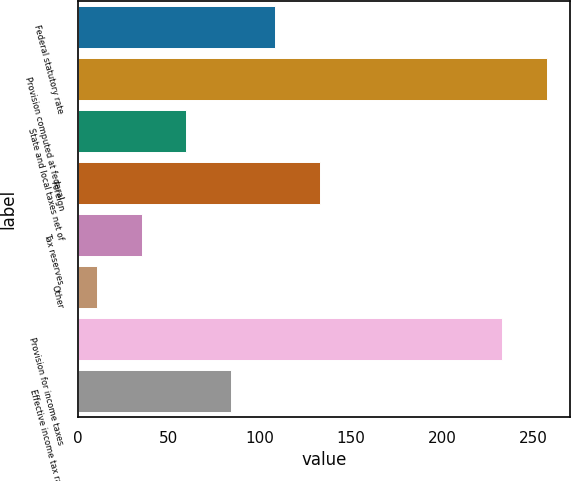Convert chart. <chart><loc_0><loc_0><loc_500><loc_500><bar_chart><fcel>Federal statutory rate<fcel>Provision computed at federal<fcel>State and local taxes net of<fcel>Foreign<fcel>Tax reserves<fcel>Other<fcel>Provision for income taxes<fcel>Effective income tax rate<nl><fcel>108.32<fcel>257.53<fcel>59.46<fcel>132.75<fcel>35.03<fcel>10.6<fcel>233.1<fcel>83.89<nl></chart> 